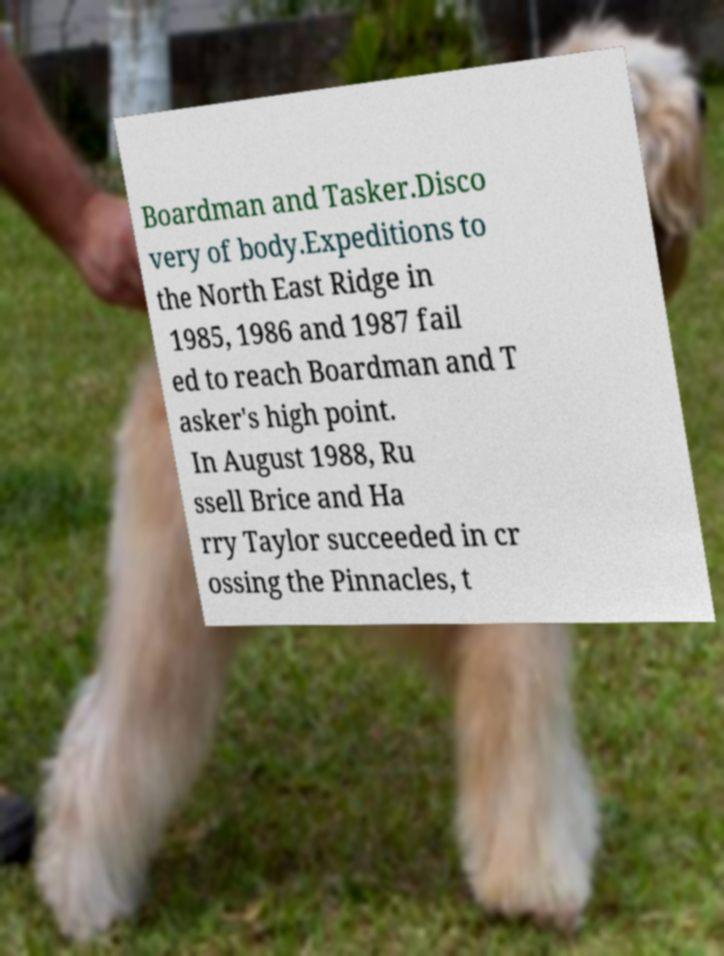Can you read and provide the text displayed in the image?This photo seems to have some interesting text. Can you extract and type it out for me? Boardman and Tasker.Disco very of body.Expeditions to the North East Ridge in 1985, 1986 and 1987 fail ed to reach Boardman and T asker's high point. In August 1988, Ru ssell Brice and Ha rry Taylor succeeded in cr ossing the Pinnacles, t 